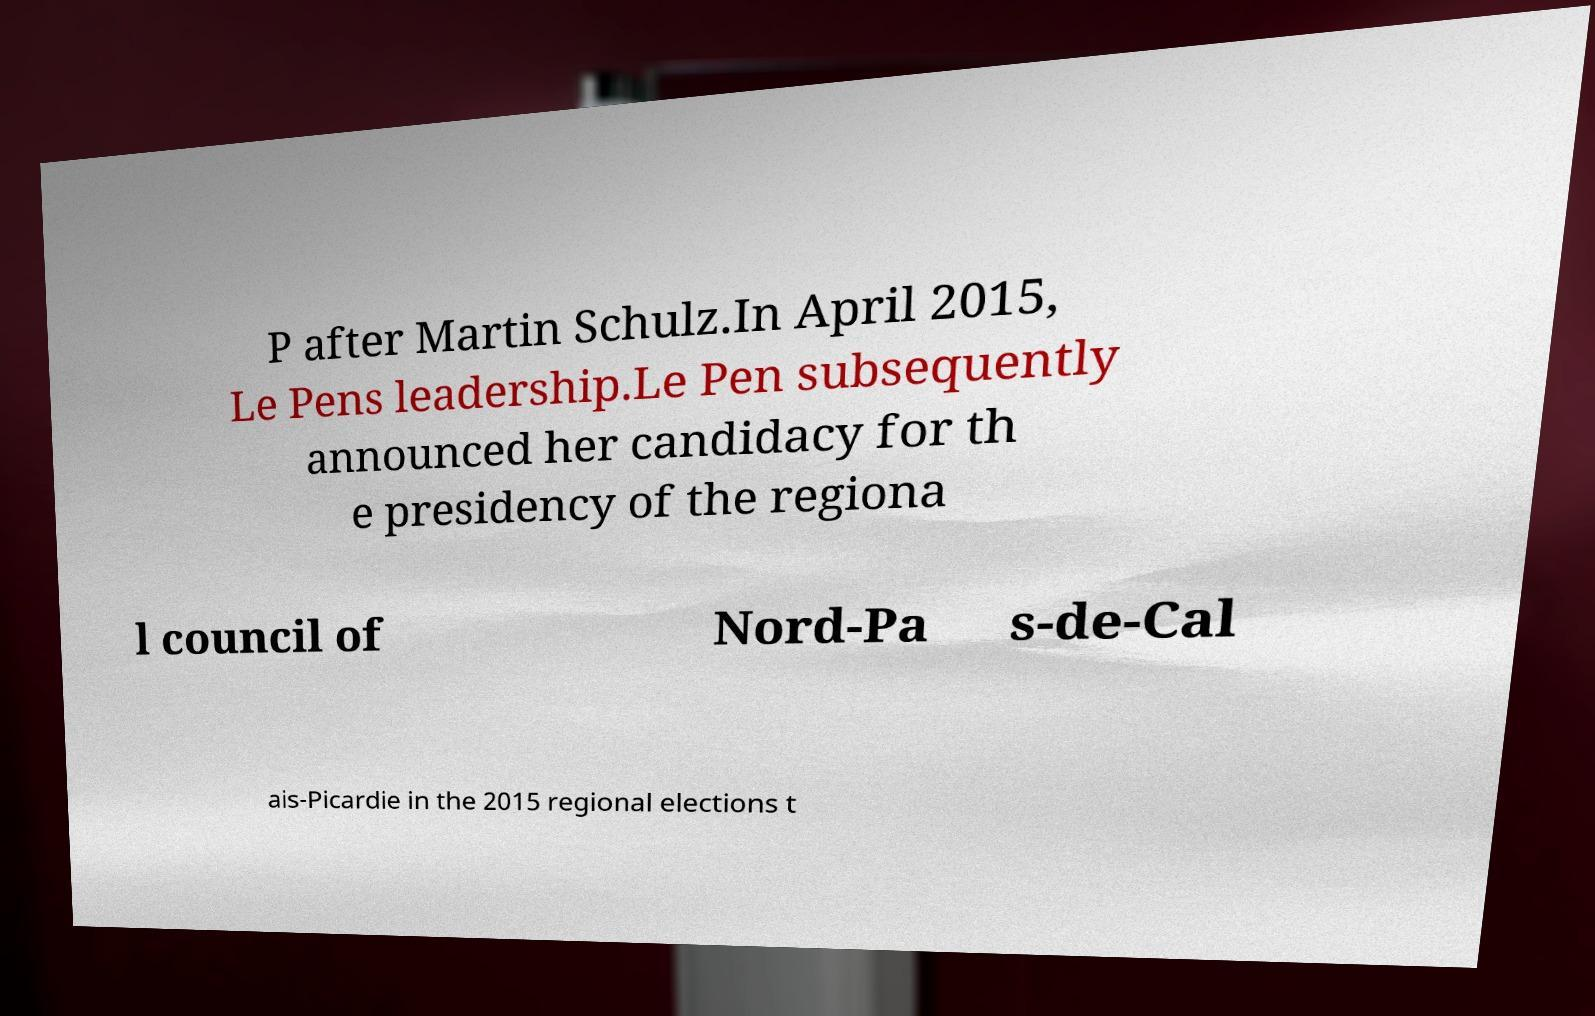Can you read and provide the text displayed in the image?This photo seems to have some interesting text. Can you extract and type it out for me? P after Martin Schulz.In April 2015, Le Pens leadership.Le Pen subsequently announced her candidacy for th e presidency of the regiona l council of Nord-Pa s-de-Cal ais-Picardie in the 2015 regional elections t 